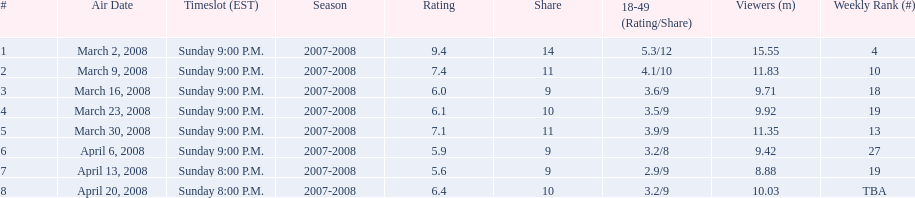Which air date had the least viewers? April 13, 2008. 